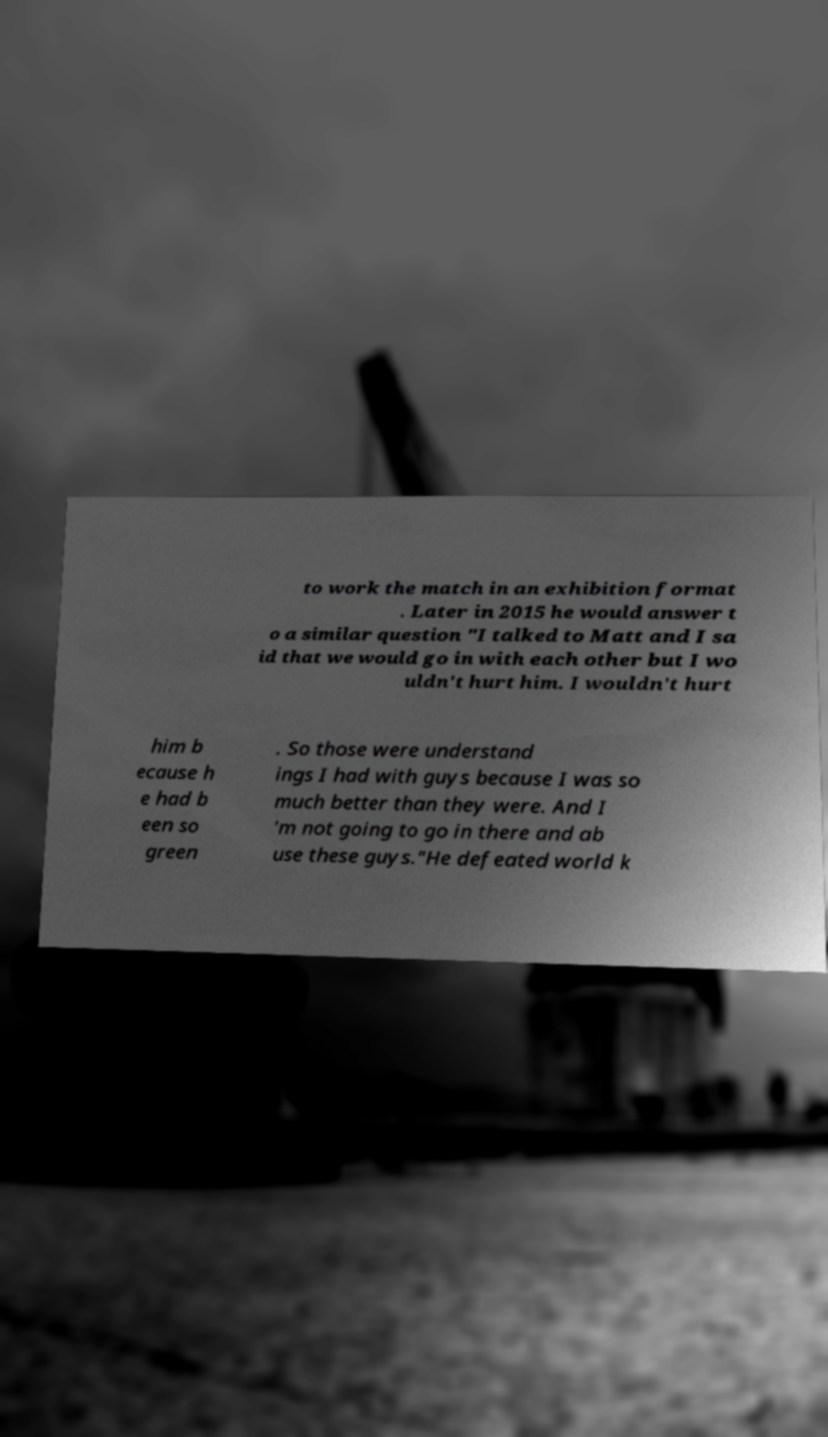I need the written content from this picture converted into text. Can you do that? to work the match in an exhibition format . Later in 2015 he would answer t o a similar question "I talked to Matt and I sa id that we would go in with each other but I wo uldn't hurt him. I wouldn't hurt him b ecause h e had b een so green . So those were understand ings I had with guys because I was so much better than they were. And I 'm not going to go in there and ab use these guys."He defeated world k 